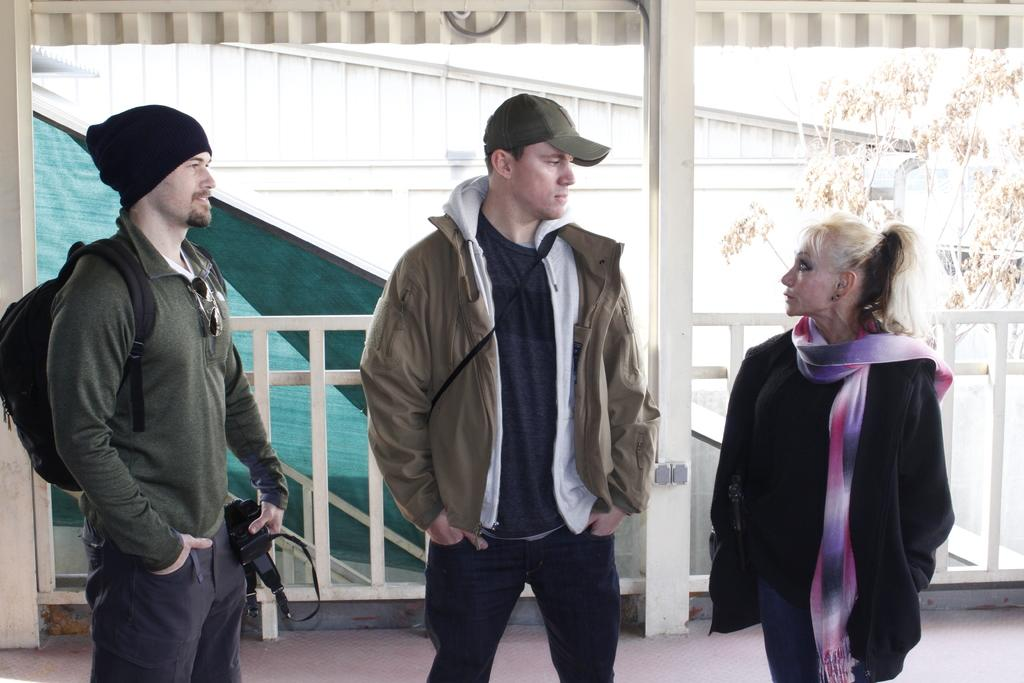How many people are present in the image? There are three people standing in the image. Can you describe the clothing of one of the men? One of the men is wearing a bag and a cap. What is the man holding in the image? The man is holding an object. What can be seen in the background of the image? There is a tree visible in the background of the image. How many cabbages are being carried by the snails in the image? There are no snails or cabbages present in the image. 